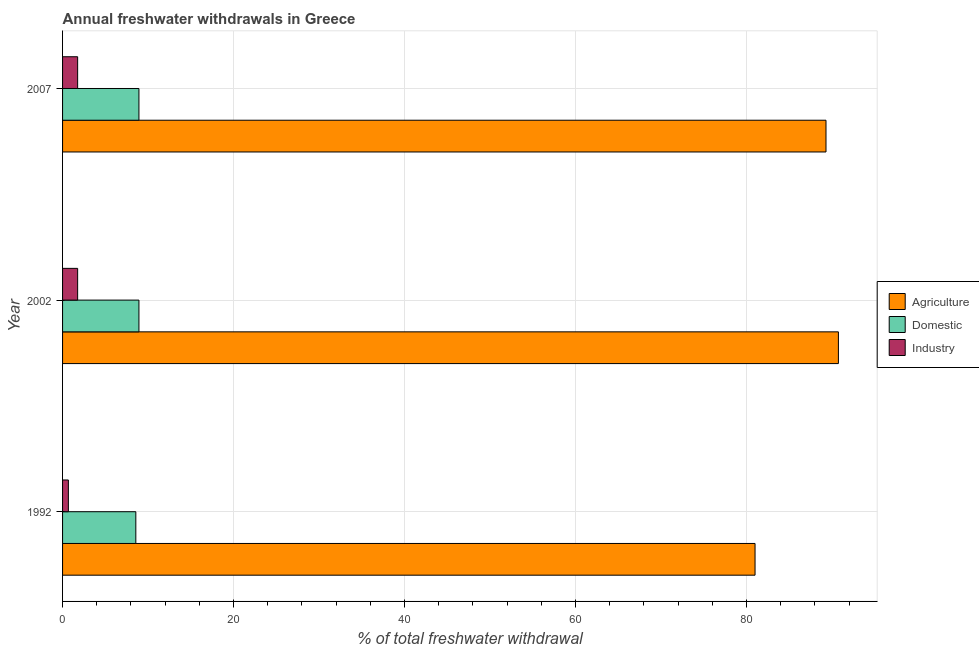Are the number of bars per tick equal to the number of legend labels?
Your response must be concise. Yes. What is the label of the 2nd group of bars from the top?
Keep it short and to the point. 2002. In how many cases, is the number of bars for a given year not equal to the number of legend labels?
Your response must be concise. 0. What is the percentage of freshwater withdrawal for domestic purposes in 1992?
Offer a terse response. 8.57. Across all years, what is the maximum percentage of freshwater withdrawal for agriculture?
Ensure brevity in your answer.  90.75. In which year was the percentage of freshwater withdrawal for agriculture minimum?
Ensure brevity in your answer.  1992. What is the total percentage of freshwater withdrawal for industry in the graph?
Provide a short and direct response. 4.21. What is the difference between the percentage of freshwater withdrawal for industry in 1992 and the percentage of freshwater withdrawal for domestic purposes in 2007?
Your response must be concise. -8.25. What is the average percentage of freshwater withdrawal for agriculture per year?
Give a very brief answer. 87.02. In the year 1992, what is the difference between the percentage of freshwater withdrawal for agriculture and percentage of freshwater withdrawal for domestic purposes?
Make the answer very short. 72.43. In how many years, is the percentage of freshwater withdrawal for industry greater than 4 %?
Keep it short and to the point. 0. What is the ratio of the percentage of freshwater withdrawal for industry in 1992 to that in 2007?
Your response must be concise. 0.39. What is the difference between the highest and the second highest percentage of freshwater withdrawal for agriculture?
Your answer should be very brief. 1.45. What is the difference between the highest and the lowest percentage of freshwater withdrawal for agriculture?
Provide a succinct answer. 9.75. What does the 2nd bar from the top in 1992 represents?
Your response must be concise. Domestic. What does the 2nd bar from the bottom in 2007 represents?
Provide a short and direct response. Domestic. How many bars are there?
Offer a very short reply. 9. Are all the bars in the graph horizontal?
Your response must be concise. Yes. Are the values on the major ticks of X-axis written in scientific E-notation?
Your answer should be compact. No. Does the graph contain any zero values?
Ensure brevity in your answer.  No. Does the graph contain grids?
Give a very brief answer. Yes. Where does the legend appear in the graph?
Provide a short and direct response. Center right. How many legend labels are there?
Make the answer very short. 3. What is the title of the graph?
Provide a short and direct response. Annual freshwater withdrawals in Greece. Does "Hydroelectric sources" appear as one of the legend labels in the graph?
Ensure brevity in your answer.  No. What is the label or title of the X-axis?
Offer a terse response. % of total freshwater withdrawal. What is the label or title of the Y-axis?
Provide a short and direct response. Year. What is the % of total freshwater withdrawal of Domestic in 1992?
Your response must be concise. 8.57. What is the % of total freshwater withdrawal in Industry in 1992?
Keep it short and to the point. 0.68. What is the % of total freshwater withdrawal in Agriculture in 2002?
Provide a short and direct response. 90.75. What is the % of total freshwater withdrawal in Domestic in 2002?
Ensure brevity in your answer.  8.93. What is the % of total freshwater withdrawal in Industry in 2002?
Give a very brief answer. 1.76. What is the % of total freshwater withdrawal of Agriculture in 2007?
Make the answer very short. 89.3. What is the % of total freshwater withdrawal of Domestic in 2007?
Provide a succinct answer. 8.93. What is the % of total freshwater withdrawal in Industry in 2007?
Ensure brevity in your answer.  1.76. Across all years, what is the maximum % of total freshwater withdrawal in Agriculture?
Your answer should be very brief. 90.75. Across all years, what is the maximum % of total freshwater withdrawal of Domestic?
Provide a succinct answer. 8.93. Across all years, what is the maximum % of total freshwater withdrawal of Industry?
Your response must be concise. 1.76. Across all years, what is the minimum % of total freshwater withdrawal of Domestic?
Make the answer very short. 8.57. Across all years, what is the minimum % of total freshwater withdrawal of Industry?
Your response must be concise. 0.68. What is the total % of total freshwater withdrawal of Agriculture in the graph?
Offer a very short reply. 261.05. What is the total % of total freshwater withdrawal in Domestic in the graph?
Make the answer very short. 26.43. What is the total % of total freshwater withdrawal of Industry in the graph?
Keep it short and to the point. 4.21. What is the difference between the % of total freshwater withdrawal in Agriculture in 1992 and that in 2002?
Your answer should be compact. -9.75. What is the difference between the % of total freshwater withdrawal of Domestic in 1992 and that in 2002?
Ensure brevity in your answer.  -0.36. What is the difference between the % of total freshwater withdrawal in Industry in 1992 and that in 2002?
Keep it short and to the point. -1.08. What is the difference between the % of total freshwater withdrawal of Agriculture in 1992 and that in 2007?
Your answer should be very brief. -8.3. What is the difference between the % of total freshwater withdrawal of Domestic in 1992 and that in 2007?
Ensure brevity in your answer.  -0.36. What is the difference between the % of total freshwater withdrawal in Industry in 1992 and that in 2007?
Make the answer very short. -1.08. What is the difference between the % of total freshwater withdrawal in Agriculture in 2002 and that in 2007?
Provide a short and direct response. 1.45. What is the difference between the % of total freshwater withdrawal in Industry in 2002 and that in 2007?
Ensure brevity in your answer.  0. What is the difference between the % of total freshwater withdrawal of Agriculture in 1992 and the % of total freshwater withdrawal of Domestic in 2002?
Ensure brevity in your answer.  72.07. What is the difference between the % of total freshwater withdrawal in Agriculture in 1992 and the % of total freshwater withdrawal in Industry in 2002?
Give a very brief answer. 79.24. What is the difference between the % of total freshwater withdrawal in Domestic in 1992 and the % of total freshwater withdrawal in Industry in 2002?
Your answer should be very brief. 6.81. What is the difference between the % of total freshwater withdrawal of Agriculture in 1992 and the % of total freshwater withdrawal of Domestic in 2007?
Your answer should be very brief. 72.07. What is the difference between the % of total freshwater withdrawal in Agriculture in 1992 and the % of total freshwater withdrawal in Industry in 2007?
Provide a short and direct response. 79.24. What is the difference between the % of total freshwater withdrawal in Domestic in 1992 and the % of total freshwater withdrawal in Industry in 2007?
Keep it short and to the point. 6.81. What is the difference between the % of total freshwater withdrawal of Agriculture in 2002 and the % of total freshwater withdrawal of Domestic in 2007?
Ensure brevity in your answer.  81.82. What is the difference between the % of total freshwater withdrawal of Agriculture in 2002 and the % of total freshwater withdrawal of Industry in 2007?
Keep it short and to the point. 88.99. What is the difference between the % of total freshwater withdrawal in Domestic in 2002 and the % of total freshwater withdrawal in Industry in 2007?
Offer a terse response. 7.17. What is the average % of total freshwater withdrawal of Agriculture per year?
Provide a short and direct response. 87.02. What is the average % of total freshwater withdrawal in Domestic per year?
Your response must be concise. 8.81. What is the average % of total freshwater withdrawal of Industry per year?
Provide a short and direct response. 1.4. In the year 1992, what is the difference between the % of total freshwater withdrawal in Agriculture and % of total freshwater withdrawal in Domestic?
Make the answer very short. 72.43. In the year 1992, what is the difference between the % of total freshwater withdrawal of Agriculture and % of total freshwater withdrawal of Industry?
Offer a terse response. 80.32. In the year 1992, what is the difference between the % of total freshwater withdrawal in Domestic and % of total freshwater withdrawal in Industry?
Your answer should be very brief. 7.89. In the year 2002, what is the difference between the % of total freshwater withdrawal in Agriculture and % of total freshwater withdrawal in Domestic?
Your answer should be compact. 81.82. In the year 2002, what is the difference between the % of total freshwater withdrawal in Agriculture and % of total freshwater withdrawal in Industry?
Your answer should be compact. 88.99. In the year 2002, what is the difference between the % of total freshwater withdrawal of Domestic and % of total freshwater withdrawal of Industry?
Offer a terse response. 7.17. In the year 2007, what is the difference between the % of total freshwater withdrawal of Agriculture and % of total freshwater withdrawal of Domestic?
Give a very brief answer. 80.37. In the year 2007, what is the difference between the % of total freshwater withdrawal in Agriculture and % of total freshwater withdrawal in Industry?
Provide a short and direct response. 87.54. In the year 2007, what is the difference between the % of total freshwater withdrawal of Domestic and % of total freshwater withdrawal of Industry?
Give a very brief answer. 7.17. What is the ratio of the % of total freshwater withdrawal in Agriculture in 1992 to that in 2002?
Your response must be concise. 0.89. What is the ratio of the % of total freshwater withdrawal in Domestic in 1992 to that in 2002?
Provide a succinct answer. 0.96. What is the ratio of the % of total freshwater withdrawal in Industry in 1992 to that in 2002?
Your response must be concise. 0.39. What is the ratio of the % of total freshwater withdrawal in Agriculture in 1992 to that in 2007?
Offer a very short reply. 0.91. What is the ratio of the % of total freshwater withdrawal in Domestic in 1992 to that in 2007?
Keep it short and to the point. 0.96. What is the ratio of the % of total freshwater withdrawal in Industry in 1992 to that in 2007?
Your response must be concise. 0.39. What is the ratio of the % of total freshwater withdrawal of Agriculture in 2002 to that in 2007?
Make the answer very short. 1.02. What is the ratio of the % of total freshwater withdrawal of Domestic in 2002 to that in 2007?
Your answer should be compact. 1. What is the ratio of the % of total freshwater withdrawal of Industry in 2002 to that in 2007?
Keep it short and to the point. 1. What is the difference between the highest and the second highest % of total freshwater withdrawal of Agriculture?
Offer a very short reply. 1.45. What is the difference between the highest and the second highest % of total freshwater withdrawal of Domestic?
Ensure brevity in your answer.  0. What is the difference between the highest and the second highest % of total freshwater withdrawal of Industry?
Your answer should be very brief. 0. What is the difference between the highest and the lowest % of total freshwater withdrawal in Agriculture?
Ensure brevity in your answer.  9.75. What is the difference between the highest and the lowest % of total freshwater withdrawal of Domestic?
Your answer should be very brief. 0.36. What is the difference between the highest and the lowest % of total freshwater withdrawal of Industry?
Offer a very short reply. 1.08. 